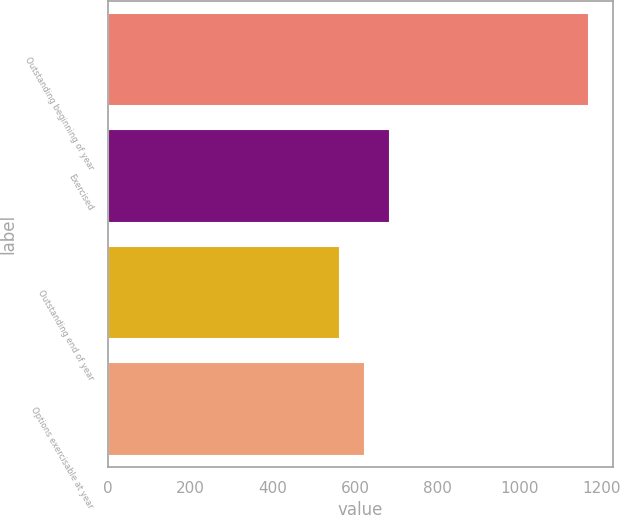<chart> <loc_0><loc_0><loc_500><loc_500><bar_chart><fcel>Outstanding beginning of year<fcel>Exercised<fcel>Outstanding end of year<fcel>Options exercisable at year<nl><fcel>1168<fcel>684<fcel>563<fcel>623.5<nl></chart> 